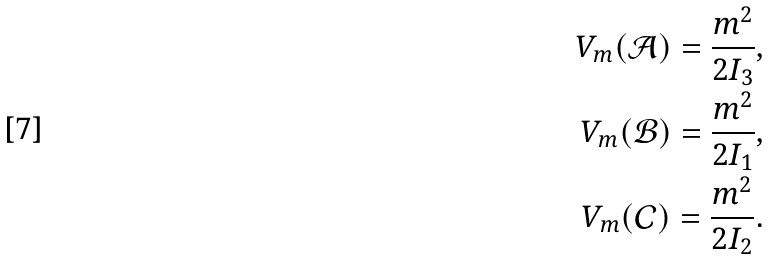Convert formula to latex. <formula><loc_0><loc_0><loc_500><loc_500>V _ { m } ( \mathcal { A } ) = \frac { m ^ { 2 } } { 2 I _ { 3 } } , \\ V _ { m } ( \mathcal { B } ) = \frac { m ^ { 2 } } { 2 I _ { 1 } } , \\ V _ { m } ( \mathcal { C } ) = \frac { m ^ { 2 } } { 2 I _ { 2 } } .</formula> 